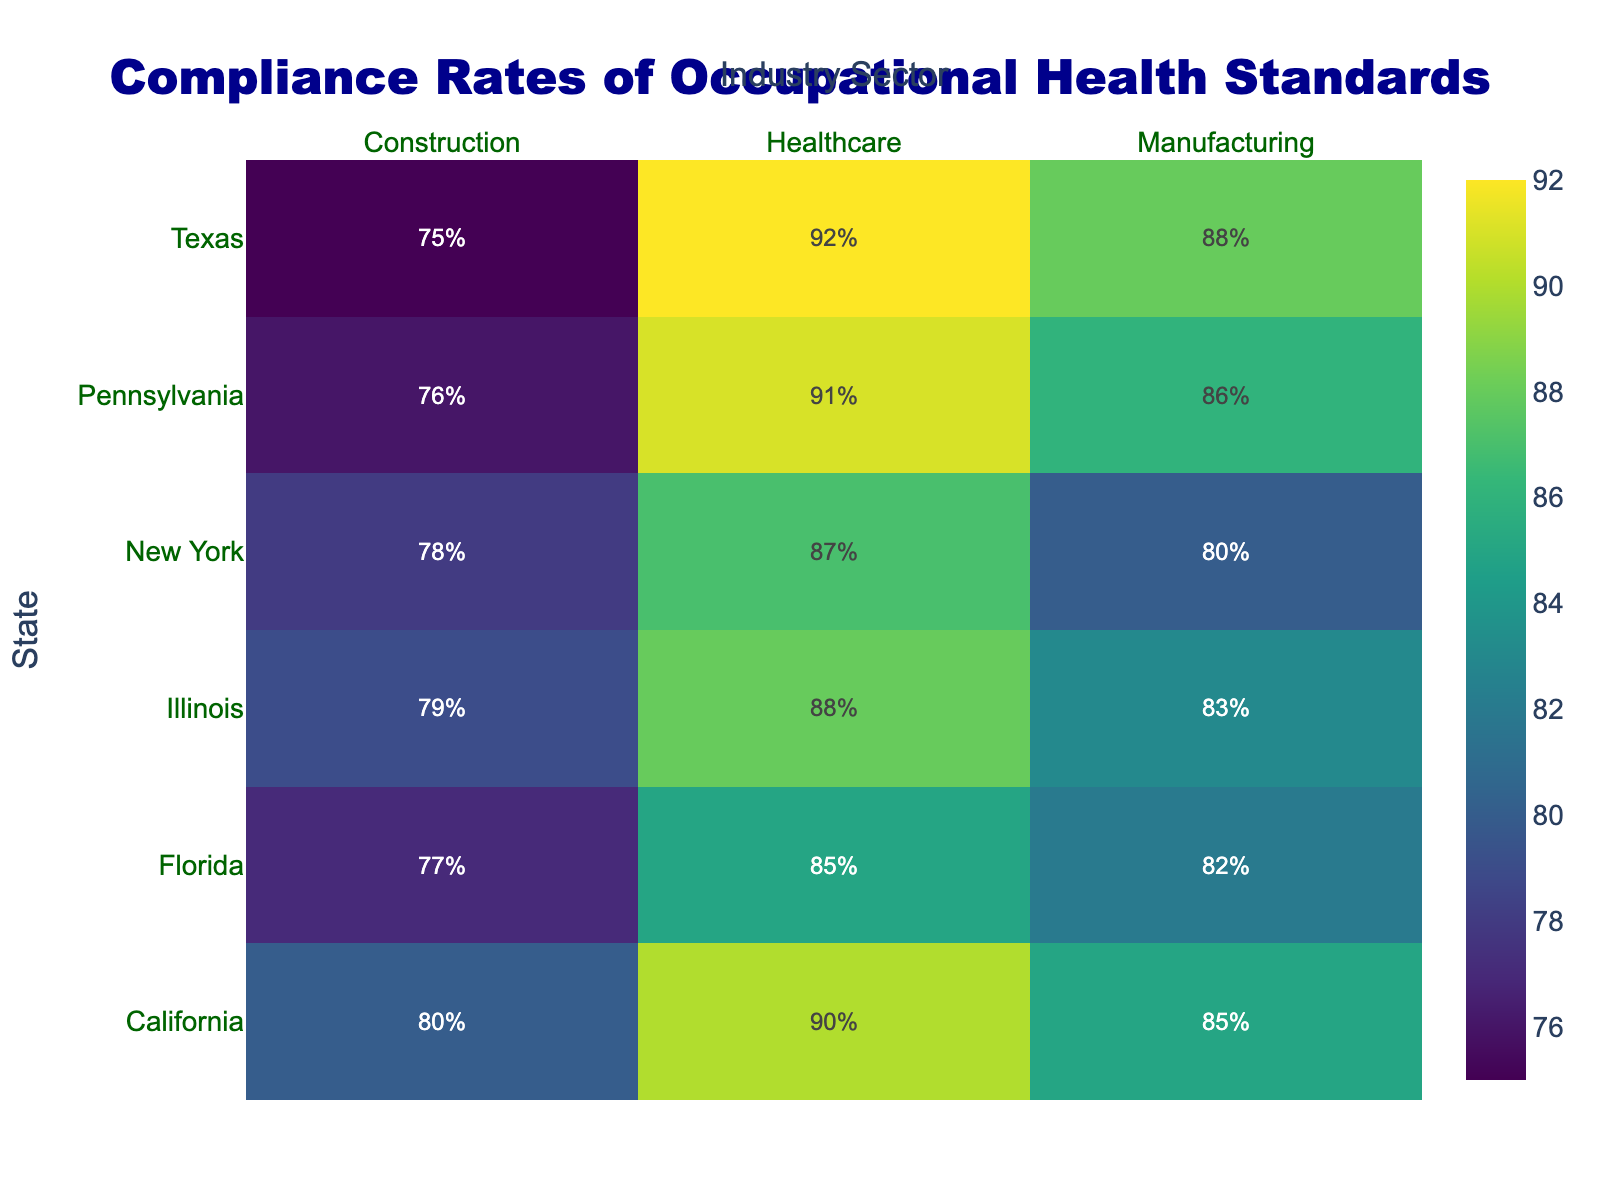What is the compliance rate for the Healthcare sector in California? Look at the intersection of the "California" row and the "Healthcare" column. The compliance rate is given here.
Answer: 90% Which state has the highest compliance rate in the Construction sector? Compare the compliance rates in the Construction sector for all states and identify the highest value.
Answer: California (80%) How does the compliance rate for Manufacturing in Texas compare to that in Florida? Locate the compliance rates for the Manufacturing sector in both Texas (88%) and Florida (82%). Then note that Texas has a higher rate.
Answer: Texas has a higher rate (88% vs 82%) What is the average compliance rate for the Healthcare sector across all states? Add up all the compliance rates for the Healthcare sector (90, 92, 87, 85, 88, 91) and divide by the number of states (6). (90+92+87+85+88+91) / 6 = 88.83
Answer: 88.83% Which industry sector in Pennsylvania has the lowest compliance rate? Compare the compliance rates in Manufacturing, Construction, and Healthcare for Pennsylvania. The lowest rate is in the Construction sector.
Answer: Construction (76%) What is the difference in compliance rates between the Healthcare sector in Texas and New York? Subtract the compliance rate for the Healthcare sector in New York (87%) from that in Texas (92%). 92 - 87 = 5
Answer: 5% Which state has the most consistent compliance rates across all industry sectors? Calculate the range (difference between the highest and lowest compliance rates) for each state and identify the smallest range.
Answer: Illinois (Manufacturing: 83, Construction: 79, Healthcare: 88; Range=9) How many states have a compliance rate of 80% or higher in Manufacturing? Count the number of states where the compliance rate in the Manufacturing sector is 80% or higher (California, Texas, Pennsylvania, Illinois, Florida).
Answer: 5 What is the overall trend in compliance rates among the three industry sectors? Observe the heatmap to determine if one sector consistently has higher or lower compliance rates compared to others. Typically, Healthcare tends to have the highest rates, followed by Manufacturing, then Construction.
Answer: Healthcare > Manufacturing > Construction 